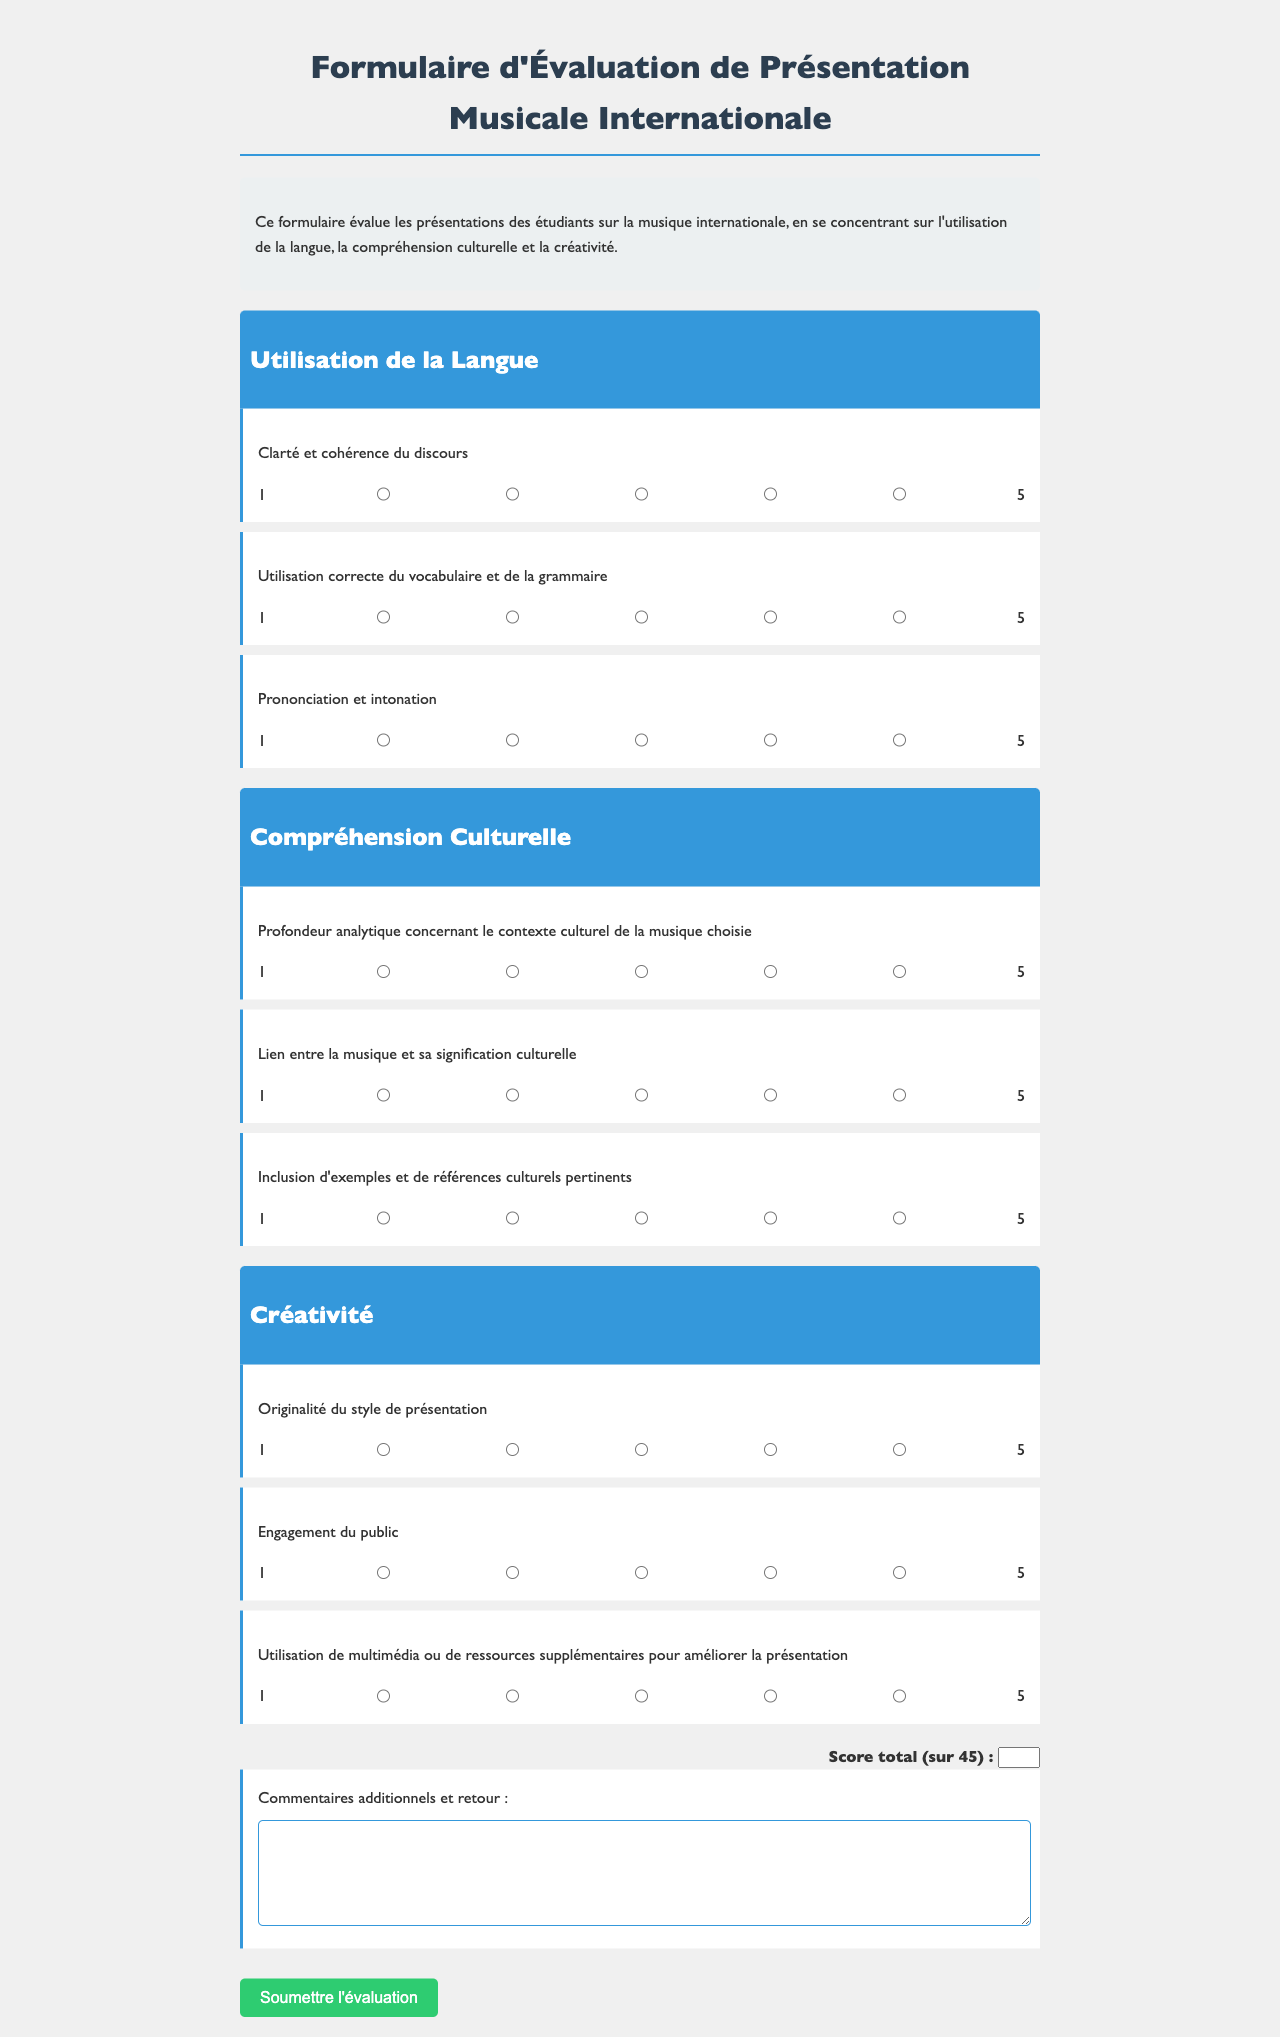Quel est le score total maximum ? Le score total maximum est indiqué dans la section "Score total", qui est sur 45.
Answer: 45 Combien de critères sont évalués dans la catégorie "Utilisation de la Langue" ? La catégorie "Utilisation de la Langue" évalue trois critères.
Answer: 3 Quel est le premier critère de la catégorie "Créativité" ? Le premier critère de la catégorie "Créativité" est mentionné comme "Originalité du style de présentation".
Answer: Originalité du style de présentation Quel type de ressources peut être utilisé pour améliorer la présentation selon le formulaire ? Le formulaire mentionne "multimédia ou de ressources supplémentaires" comme pouvant être utilisé pour améliorer la présentation.
Answer: multimédia Quel élément est requis pour des commentaires supplémentaires ? Le formulaire inclut un champ de texte pour des "Commentaires additionnels et retour".
Answer: Commentaires additionnels et retour Quel est le nom du formulaire ? Le nom du formulaire est affiché en haut comme "Formulaire d'Évaluation de Présentation Musicale Internationale".
Answer: Formulaire d'Évaluation de Présentation Musicale Internationale Quel est le critère d'évaluation de la prononciation ? Le critère d'évaluation de la prononciation est "Prononciation et intonation".
Answer: Prononciation et intonation Quel est le nombre total de critères évalués dans la section "Compréhension Culturelle" ? La section "Compréhension Culturelle" évalue trois critères.
Answer: 3 Quel est le texte d'introduction du formulaire ? L'introduction explique que le formulaire évalue les présentations des étudiants sur la musique internationale.
Answer: Ce formulaire évalue les présentations des étudiants sur la musique internationale, en se concentrant sur l'utilisation de la langue, la compréhension culturelle et la créativité 